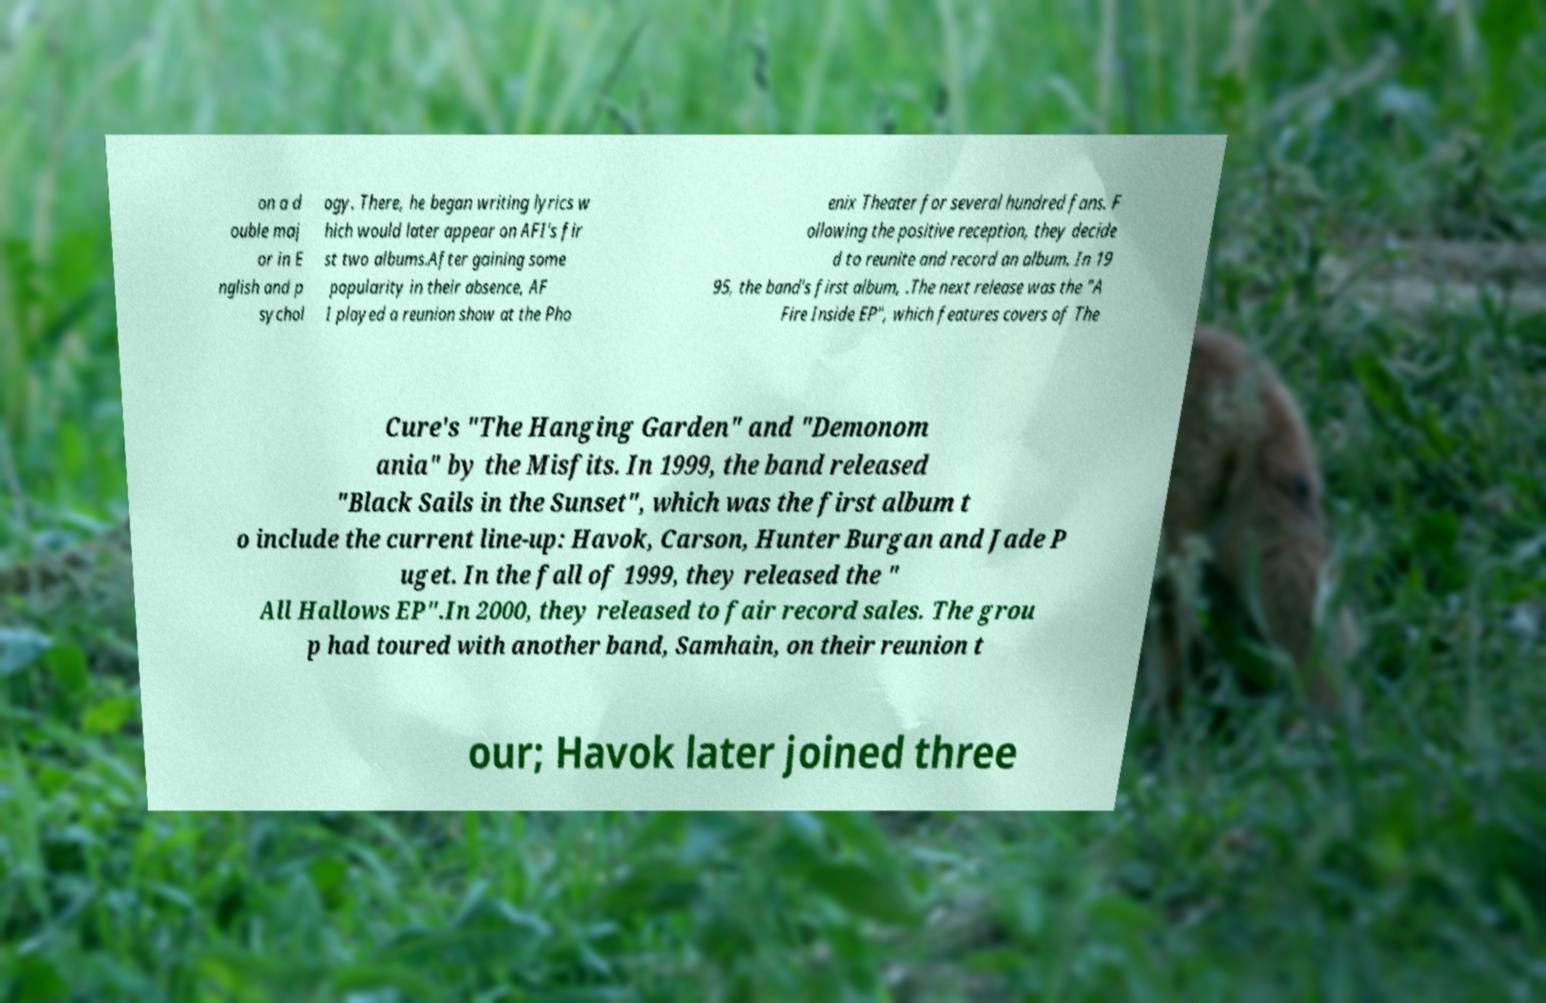Please identify and transcribe the text found in this image. on a d ouble maj or in E nglish and p sychol ogy. There, he began writing lyrics w hich would later appear on AFI's fir st two albums.After gaining some popularity in their absence, AF I played a reunion show at the Pho enix Theater for several hundred fans. F ollowing the positive reception, they decide d to reunite and record an album. In 19 95, the band's first album, .The next release was the "A Fire Inside EP", which features covers of The Cure's "The Hanging Garden" and "Demonom ania" by the Misfits. In 1999, the band released "Black Sails in the Sunset", which was the first album t o include the current line-up: Havok, Carson, Hunter Burgan and Jade P uget. In the fall of 1999, they released the " All Hallows EP".In 2000, they released to fair record sales. The grou p had toured with another band, Samhain, on their reunion t our; Havok later joined three 